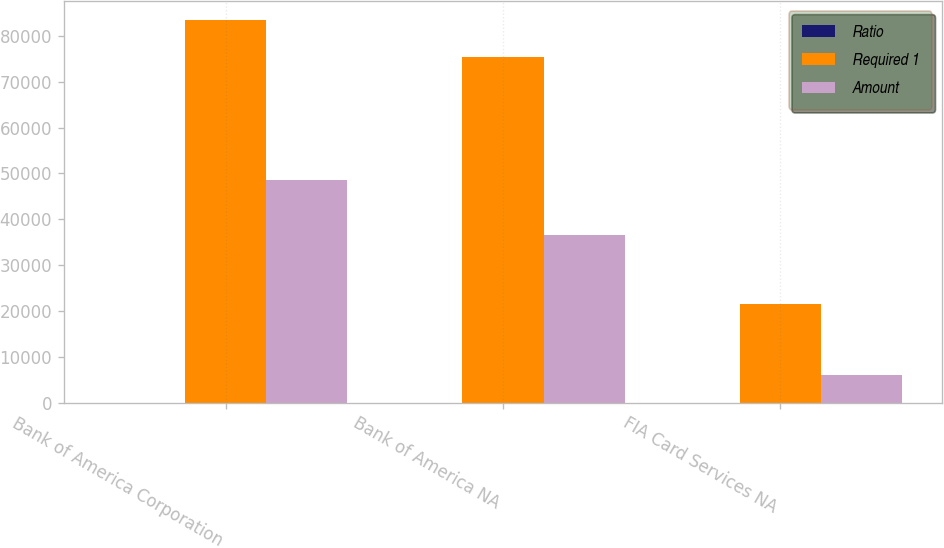Convert chart. <chart><loc_0><loc_0><loc_500><loc_500><stacked_bar_chart><ecel><fcel>Bank of America Corporation<fcel>Bank of America NA<fcel>FIA Card Services NA<nl><fcel>Ratio<fcel>6.87<fcel>8.23<fcel>14.29<nl><fcel>Required 1<fcel>83372<fcel>75395<fcel>21625<nl><fcel>Amount<fcel>48516<fcel>36661<fcel>6053<nl></chart> 